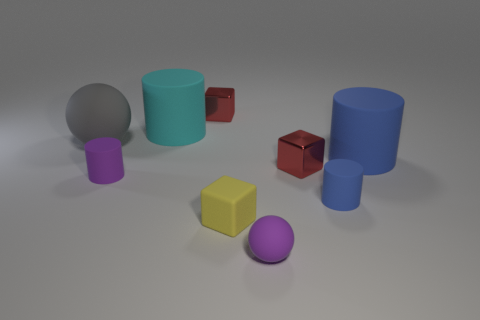What number of tiny red metallic objects are to the right of the blue object right of the tiny blue matte cylinder?
Provide a short and direct response. 0. What number of other things are made of the same material as the big ball?
Offer a very short reply. 6. Does the red block that is behind the big gray rubber thing have the same material as the small red thing right of the tiny purple matte ball?
Your answer should be compact. Yes. Is the purple cylinder made of the same material as the small red object that is left of the tiny yellow rubber cube?
Offer a terse response. No. What is the color of the small metallic block on the left side of the small block that is right of the purple rubber sphere that is in front of the tiny yellow matte object?
Make the answer very short. Red. What is the shape of the blue thing that is the same size as the cyan object?
Your response must be concise. Cylinder. Are there any other things that are the same size as the matte block?
Offer a terse response. Yes. Does the cyan matte cylinder to the right of the large gray thing have the same size as the rubber ball that is behind the big blue object?
Ensure brevity in your answer.  Yes. There is a matte object that is left of the tiny purple matte cylinder; what is its size?
Your response must be concise. Large. What material is the tiny object that is the same color as the small ball?
Your answer should be compact. Rubber. 